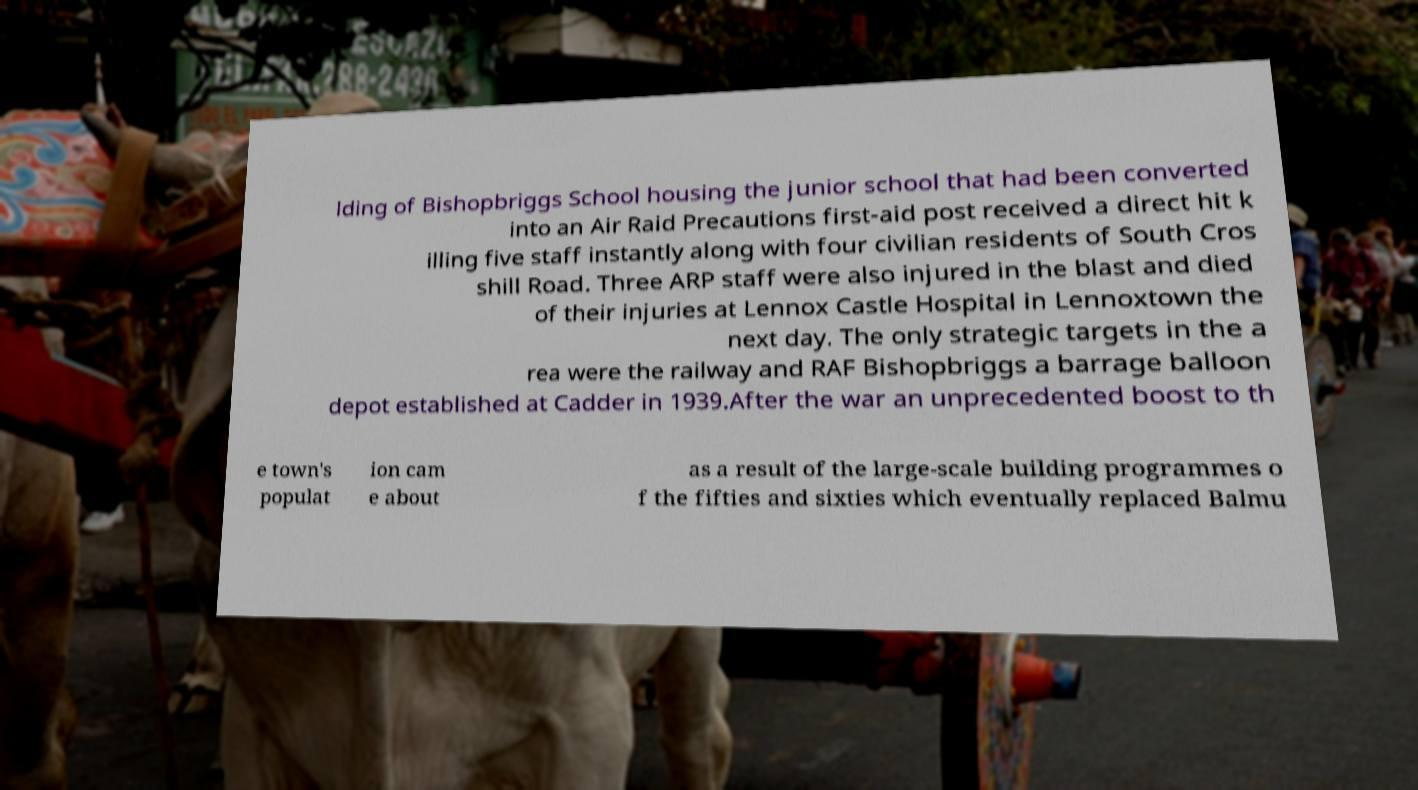Can you read and provide the text displayed in the image?This photo seems to have some interesting text. Can you extract and type it out for me? lding of Bishopbriggs School housing the junior school that had been converted into an Air Raid Precautions first-aid post received a direct hit k illing five staff instantly along with four civilian residents of South Cros shill Road. Three ARP staff were also injured in the blast and died of their injuries at Lennox Castle Hospital in Lennoxtown the next day. The only strategic targets in the a rea were the railway and RAF Bishopbriggs a barrage balloon depot established at Cadder in 1939.After the war an unprecedented boost to th e town's populat ion cam e about as a result of the large-scale building programmes o f the fifties and sixties which eventually replaced Balmu 